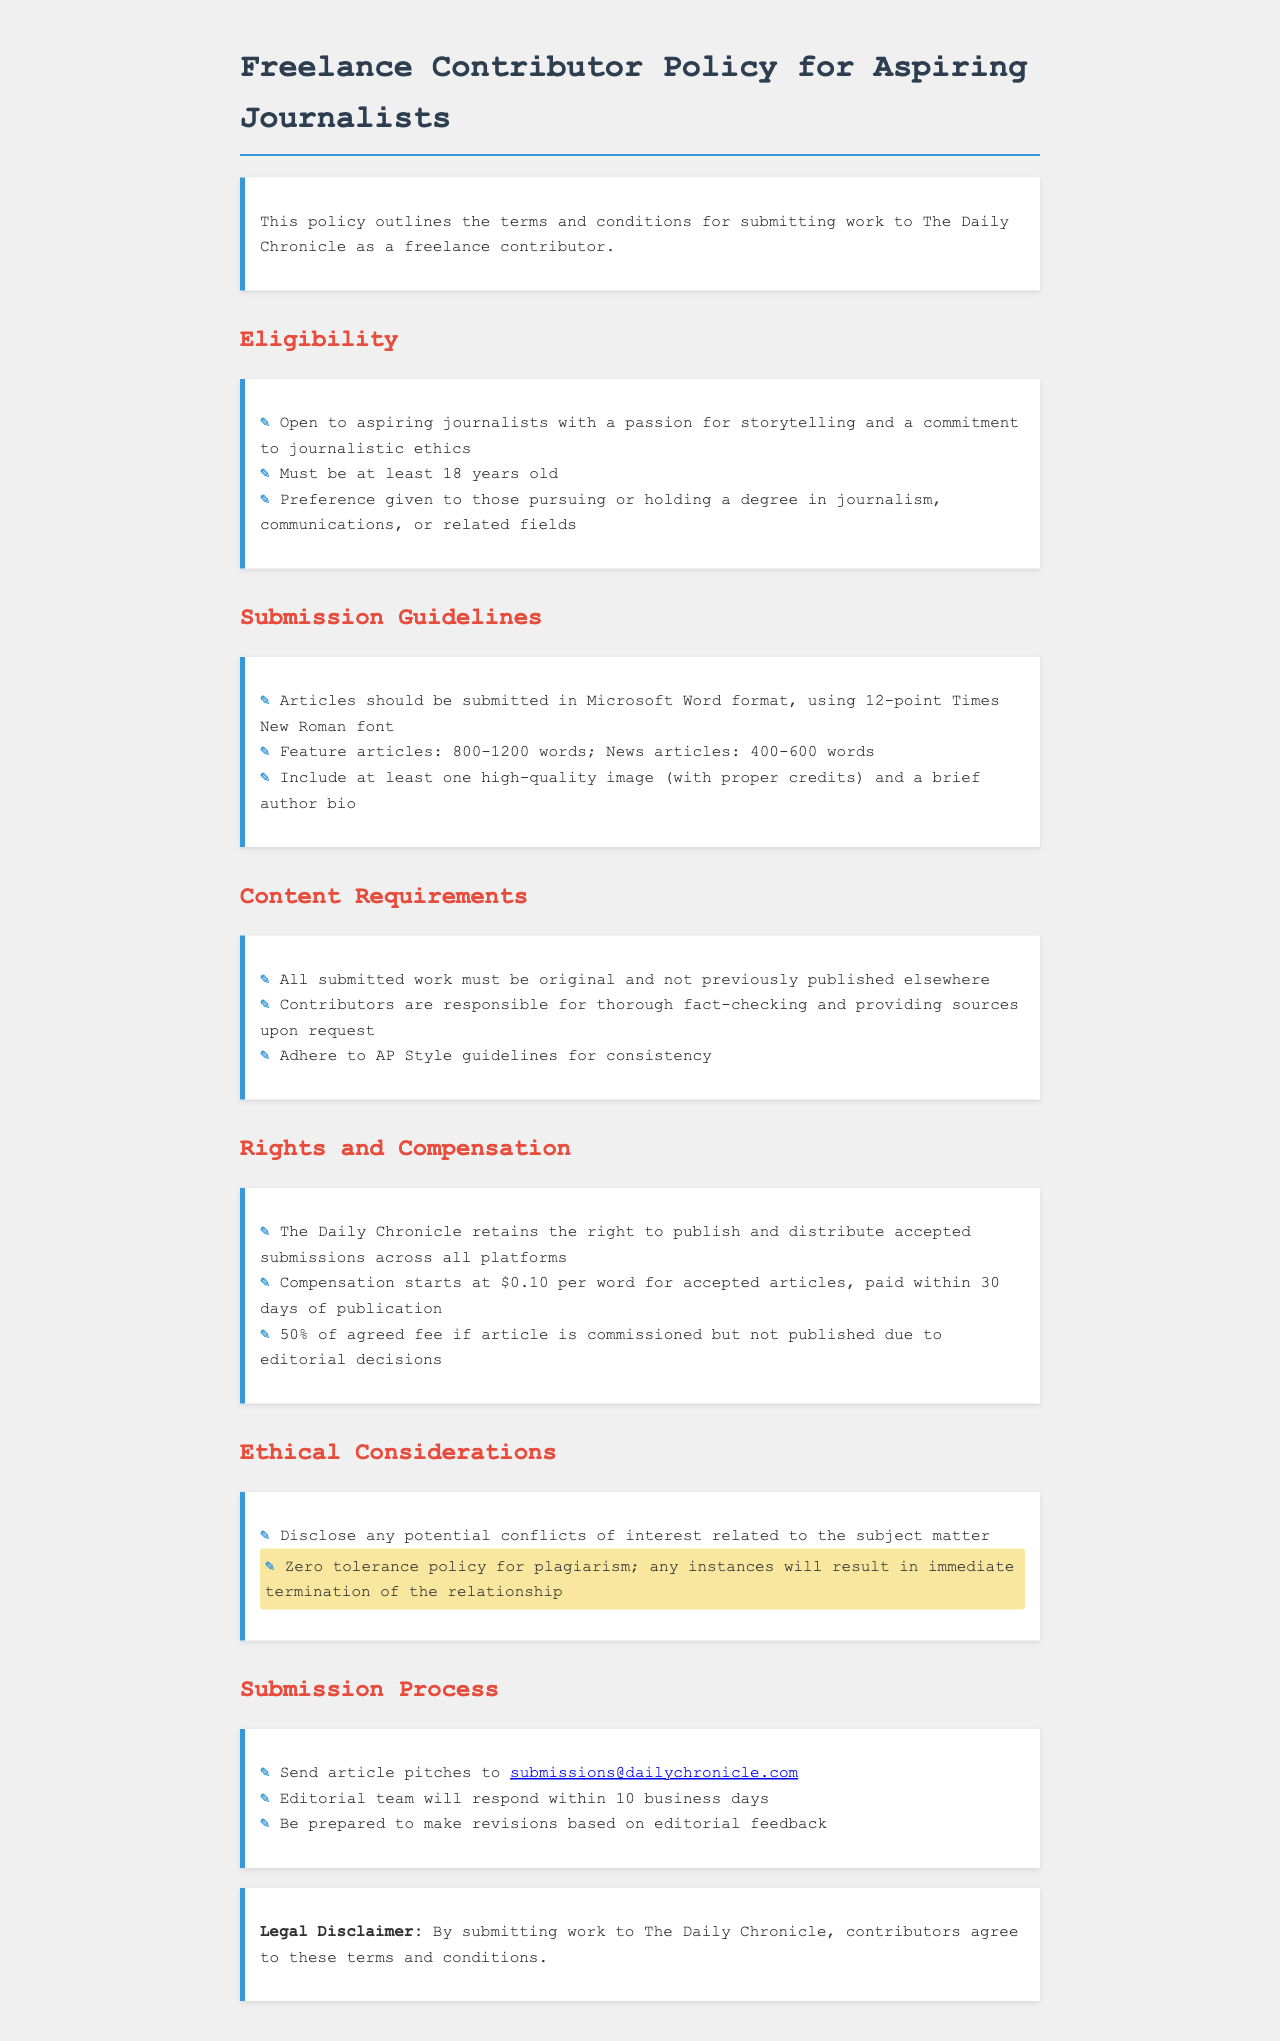What is the minimum age to apply? The document states that applicants must be at least 18 years old to be eligible.
Answer: 18 years old What format should articles be submitted in? The submission guidelines specify that articles should be submitted in Microsoft Word format.
Answer: Microsoft Word format What is the word count range for feature articles? The document outlines the word count range for feature articles as between 800 and 1200 words.
Answer: 800-1200 words What compensation rate is mentioned for accepted articles? The document states that compensation starts at $0.10 per word for accepted articles.
Answer: $0.10 per word What is required for articles to be considered for publication? According to the content requirements, all submitted work must be original and not previously published elsewhere.
Answer: Original work What happens to articles that are commissioned but not published? The policy states that contributors receive 50% of the agreed fee for commissioned articles not published due to editorial decisions.
Answer: 50% How soon will the editorial team respond to submissions? The document mentions that the editorial team will respond within 10 business days.
Answer: 10 business days What should contributors disclose according to ethical considerations? Contributors are required to disclose any potential conflicts of interest related to the subject matter.
Answer: Conflicts of interest What happens in cases of plagiarism? The document clearly states there is a zero tolerance policy for plagiarism resulting in immediate termination of the relationship.
Answer: Immediate termination 